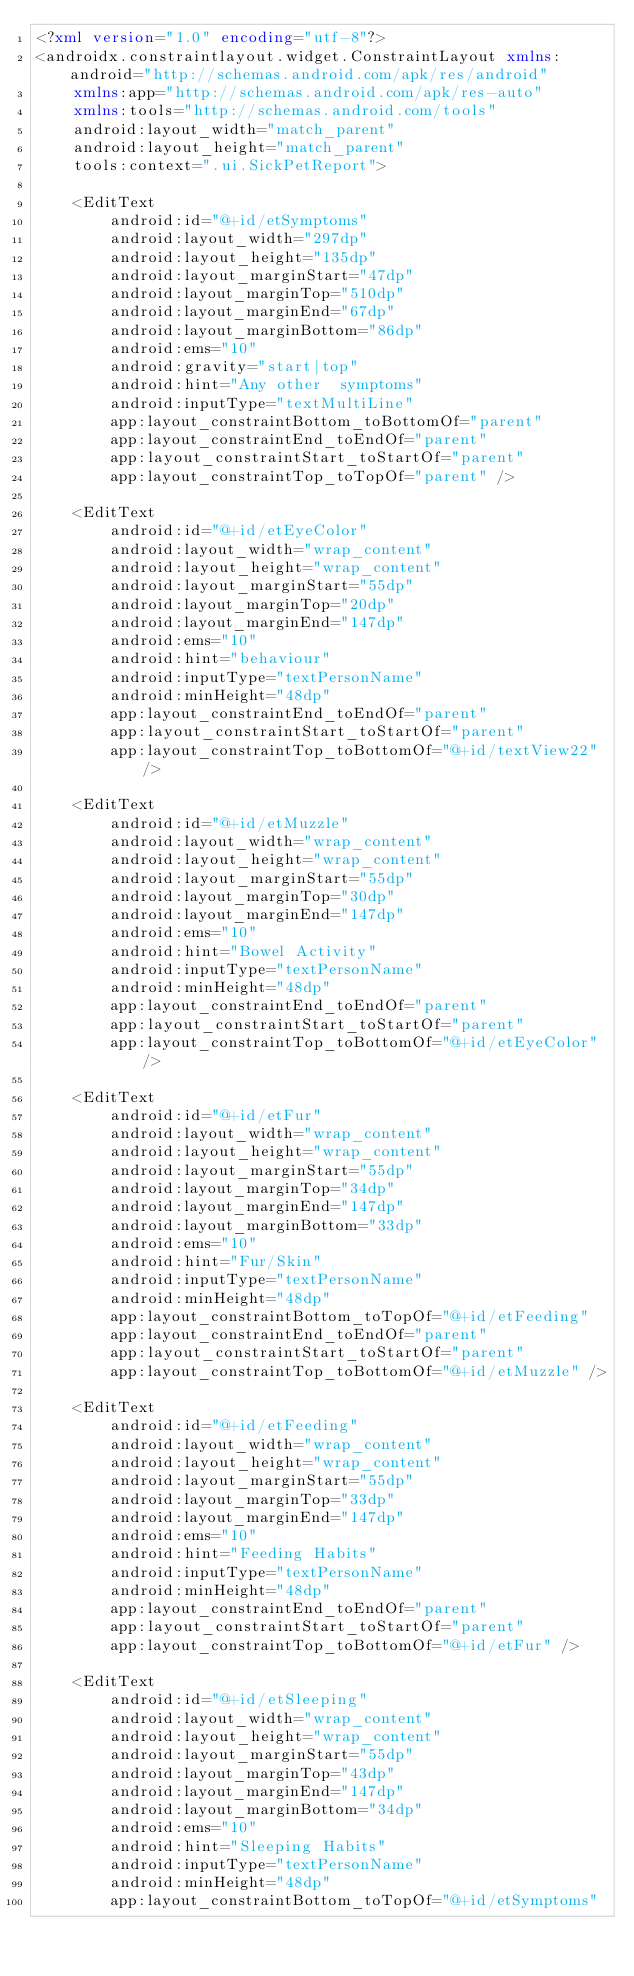<code> <loc_0><loc_0><loc_500><loc_500><_XML_><?xml version="1.0" encoding="utf-8"?>
<androidx.constraintlayout.widget.ConstraintLayout xmlns:android="http://schemas.android.com/apk/res/android"
    xmlns:app="http://schemas.android.com/apk/res-auto"
    xmlns:tools="http://schemas.android.com/tools"
    android:layout_width="match_parent"
    android:layout_height="match_parent"
    tools:context=".ui.SickPetReport">

    <EditText
        android:id="@+id/etSymptoms"
        android:layout_width="297dp"
        android:layout_height="135dp"
        android:layout_marginStart="47dp"
        android:layout_marginTop="510dp"
        android:layout_marginEnd="67dp"
        android:layout_marginBottom="86dp"
        android:ems="10"
        android:gravity="start|top"
        android:hint="Any other  symptoms"
        android:inputType="textMultiLine"
        app:layout_constraintBottom_toBottomOf="parent"
        app:layout_constraintEnd_toEndOf="parent"
        app:layout_constraintStart_toStartOf="parent"
        app:layout_constraintTop_toTopOf="parent" />

    <EditText
        android:id="@+id/etEyeColor"
        android:layout_width="wrap_content"
        android:layout_height="wrap_content"
        android:layout_marginStart="55dp"
        android:layout_marginTop="20dp"
        android:layout_marginEnd="147dp"
        android:ems="10"
        android:hint="behaviour"
        android:inputType="textPersonName"
        android:minHeight="48dp"
        app:layout_constraintEnd_toEndOf="parent"
        app:layout_constraintStart_toStartOf="parent"
        app:layout_constraintTop_toBottomOf="@+id/textView22" />

    <EditText
        android:id="@+id/etMuzzle"
        android:layout_width="wrap_content"
        android:layout_height="wrap_content"
        android:layout_marginStart="55dp"
        android:layout_marginTop="30dp"
        android:layout_marginEnd="147dp"
        android:ems="10"
        android:hint="Bowel Activity"
        android:inputType="textPersonName"
        android:minHeight="48dp"
        app:layout_constraintEnd_toEndOf="parent"
        app:layout_constraintStart_toStartOf="parent"
        app:layout_constraintTop_toBottomOf="@+id/etEyeColor" />

    <EditText
        android:id="@+id/etFur"
        android:layout_width="wrap_content"
        android:layout_height="wrap_content"
        android:layout_marginStart="55dp"
        android:layout_marginTop="34dp"
        android:layout_marginEnd="147dp"
        android:layout_marginBottom="33dp"
        android:ems="10"
        android:hint="Fur/Skin"
        android:inputType="textPersonName"
        android:minHeight="48dp"
        app:layout_constraintBottom_toTopOf="@+id/etFeeding"
        app:layout_constraintEnd_toEndOf="parent"
        app:layout_constraintStart_toStartOf="parent"
        app:layout_constraintTop_toBottomOf="@+id/etMuzzle" />

    <EditText
        android:id="@+id/etFeeding"
        android:layout_width="wrap_content"
        android:layout_height="wrap_content"
        android:layout_marginStart="55dp"
        android:layout_marginTop="33dp"
        android:layout_marginEnd="147dp"
        android:ems="10"
        android:hint="Feeding Habits"
        android:inputType="textPersonName"
        android:minHeight="48dp"
        app:layout_constraintEnd_toEndOf="parent"
        app:layout_constraintStart_toStartOf="parent"
        app:layout_constraintTop_toBottomOf="@+id/etFur" />

    <EditText
        android:id="@+id/etSleeping"
        android:layout_width="wrap_content"
        android:layout_height="wrap_content"
        android:layout_marginStart="55dp"
        android:layout_marginTop="43dp"
        android:layout_marginEnd="147dp"
        android:layout_marginBottom="34dp"
        android:ems="10"
        android:hint="Sleeping Habits"
        android:inputType="textPersonName"
        android:minHeight="48dp"
        app:layout_constraintBottom_toTopOf="@+id/etSymptoms"</code> 